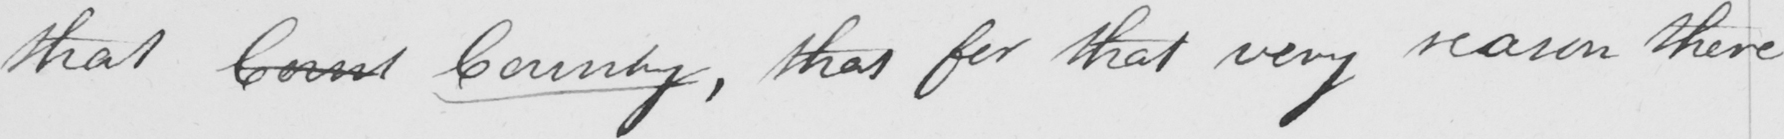Transcribe the text shown in this historical manuscript line. that Count Country , that for that very reason there 